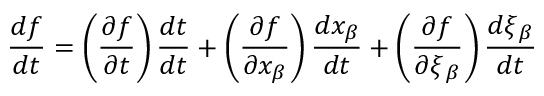Convert formula to latex. <formula><loc_0><loc_0><loc_500><loc_500>\frac { d f } { d t } = \left ( \frac { \partial { f } } { \partial { t } } \right ) \frac { d t } { d t } + \left ( \frac { \partial { f } } { \partial { x _ { \beta } } } \right ) \frac { d x _ { \beta } } { d t } + \left ( \frac { \partial { f } } { \partial { \xi { _ { \beta } } } } \right ) \frac { d \xi { _ { \beta } } } { d t }</formula> 